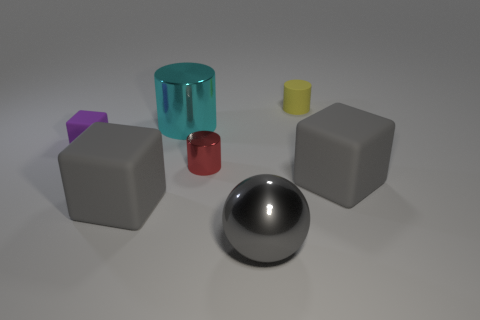Subtract all tiny matte cubes. How many cubes are left? 2 Add 2 brown matte blocks. How many objects exist? 9 Subtract all purple cubes. How many cubes are left? 2 Subtract all cylinders. How many objects are left? 4 Subtract all green cubes. Subtract all red spheres. How many cubes are left? 3 Subtract all gray blocks. How many red cylinders are left? 1 Subtract all cyan shiny spheres. Subtract all yellow objects. How many objects are left? 6 Add 6 purple blocks. How many purple blocks are left? 7 Add 2 small blue rubber balls. How many small blue rubber balls exist? 2 Subtract 1 yellow cylinders. How many objects are left? 6 